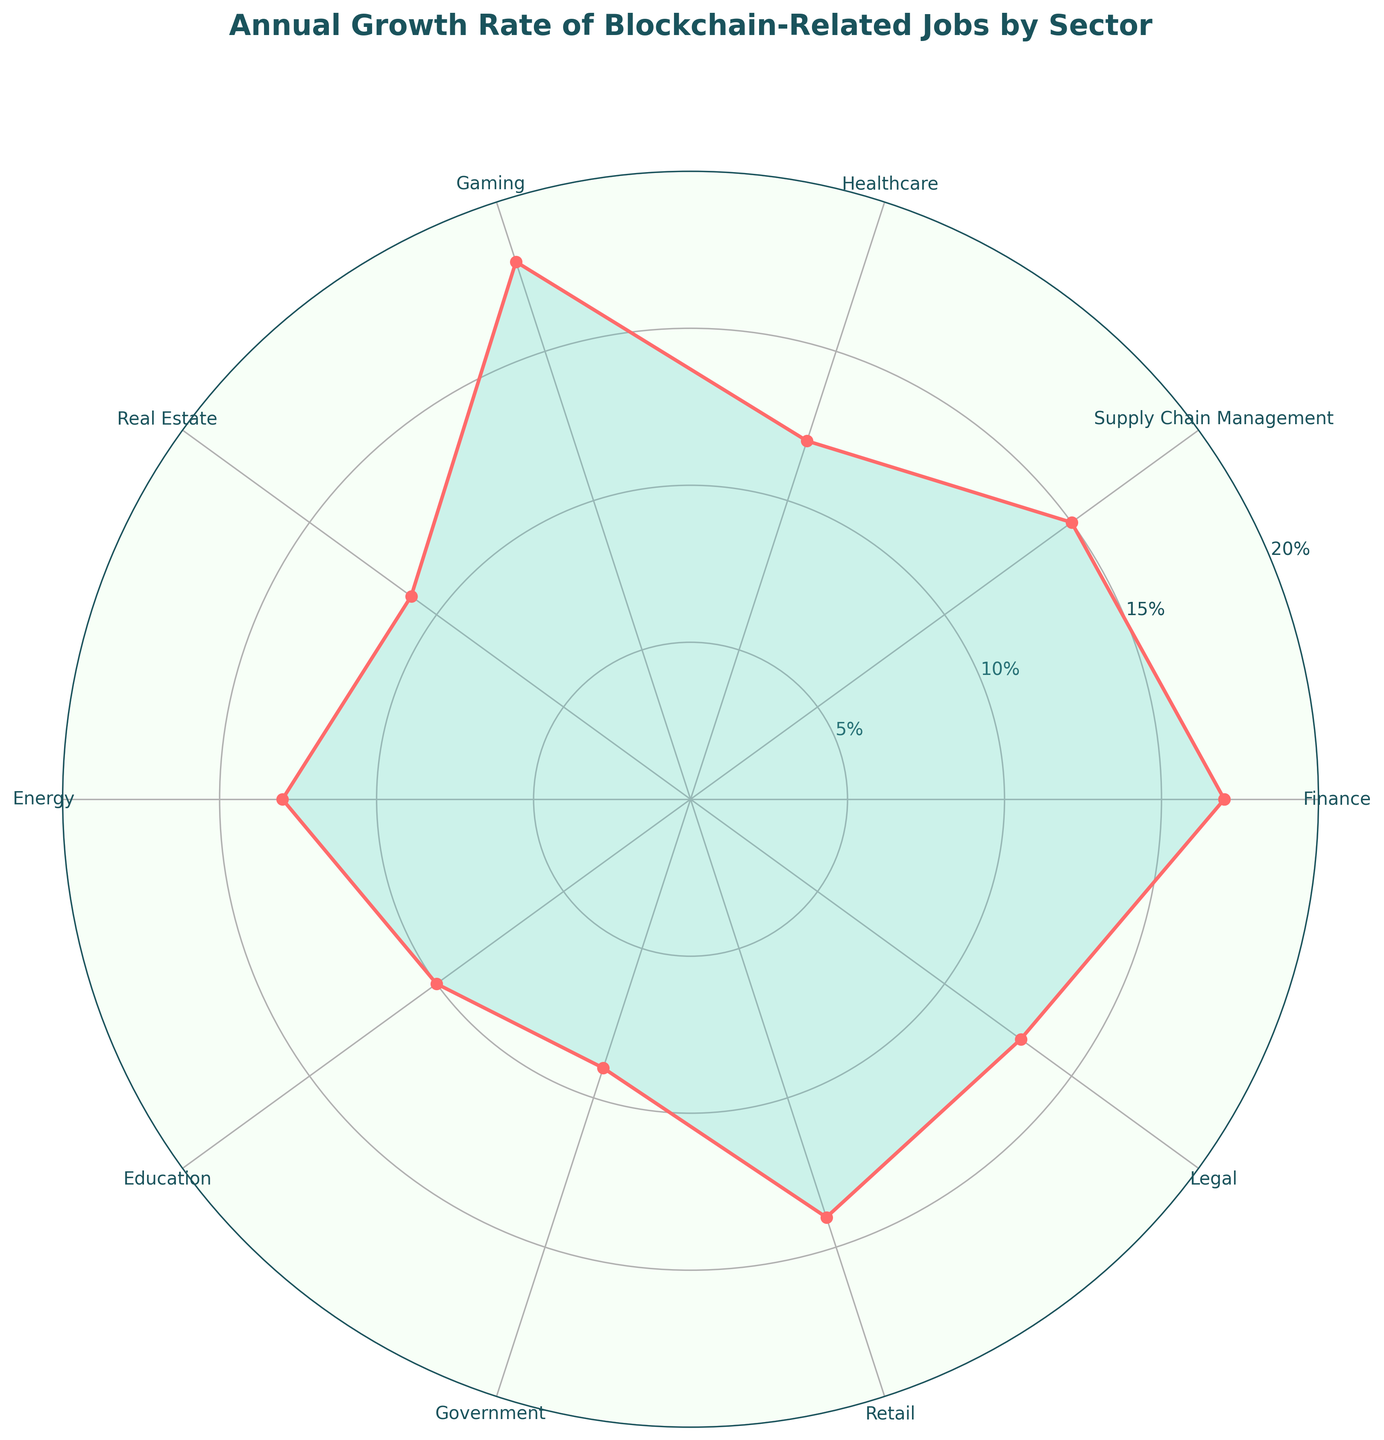What's the title of the figure? The title of the figure is prominently displayed at the top of the plot. It reads, 'Annual Growth Rate of Blockchain-Related Jobs by Sector'.
Answer: Annual Growth Rate of Blockchain-Related Jobs by Sector What are the highest and lowest growth rates shown in the chart? Looking at the plot, the highest growth rate is represented by the longest petal and the lowest by the shortest. Gaming has the highest rate at 18% and Government has the lowest at 9%.
Answer: Highest: 18%, Lowest: 9% Which sector has a growth rate of 12%? Each sector corresponds to a specific angle with its respective percentage. Healthcare is the sector showing an annual growth rate of 12%.
Answer: Healthcare What is the average annual growth rate across all sectors? Adding the growth rates: 17 (Finance) + 15 (Supply Chain Management) + 12 (Healthcare) + 18 (Gaming) + 11 (Real Estate) + 13 (Energy) + 10 (Education) + 9 (Government) + 14 (Retail) + 13 (Legal) = 132. Dividing by the number of sectors (10) we get: 132/10 = 13.2%.
Answer: 13.2% Which two sectors have the same growth rate, and what is it? By noting the lengths of the petals and their associated sectors, Energy and Legal both show a growth rate of 13%.
Answer: Energy and Legal, 13% How much higher is the growth rate of Gaming compared to Government? Gaming has a growth rate of 18% and Government has 9%. The difference is: 18% - 9% = 9%.
Answer: 9% What is the growth rate of the Retail sector? Looking at the labeled sectors around the plot, Retail's growth rate is 14%.
Answer: 14% Which sector is positioned immediately next to the Finance sector on the plot? In the plot, sectors are arranged sequentially around the circle. Supply Chain Management is next to Finance.
Answer: Supply Chain Management What is the median annual growth rate shown in the chart? Sorting the growth rates: 9 (Government), 10 (Education), 11 (Real Estate), 12 (Healthcare), 13 (Energy), 13 (Legal), 14 (Retail), 15 (Supply Chain Management), 17 (Finance), 18 (Gaming). The median, being the average of the middle two values (13 and 13), is: (13+13)/2 = 13%.
Answer: 13% What colors are used to fill and outline the plot data points? The petals are filled with a light greenish-blue color and outlined with a red color.
Answer: Filled with greenish-blue, outlined with red 